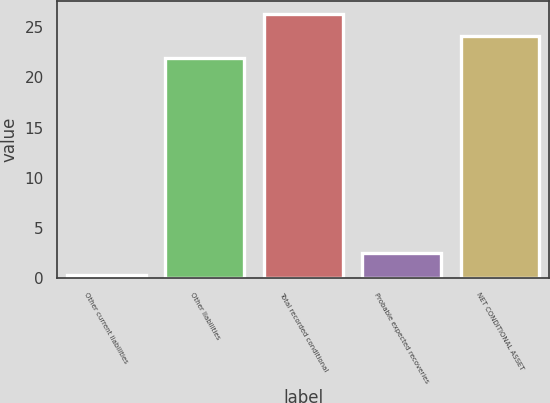Convert chart to OTSL. <chart><loc_0><loc_0><loc_500><loc_500><bar_chart><fcel>Other current liabilities<fcel>Other liabilities<fcel>Total recorded conditional<fcel>Probable expected recoveries<fcel>NET CONDITIONAL ASSET<nl><fcel>0.3<fcel>21.9<fcel>26.28<fcel>2.49<fcel>24.09<nl></chart> 